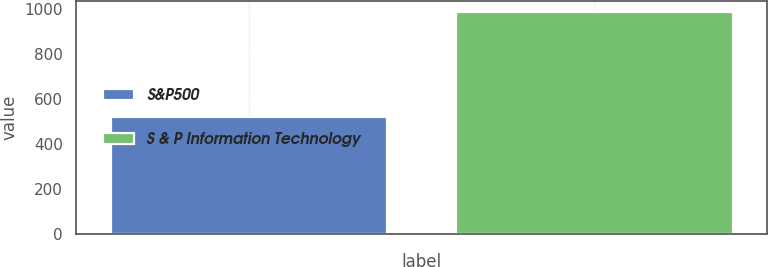Convert chart to OTSL. <chart><loc_0><loc_0><loc_500><loc_500><bar_chart><fcel>S&P500<fcel>S & P Information Technology<nl><fcel>521.45<fcel>989.28<nl></chart> 